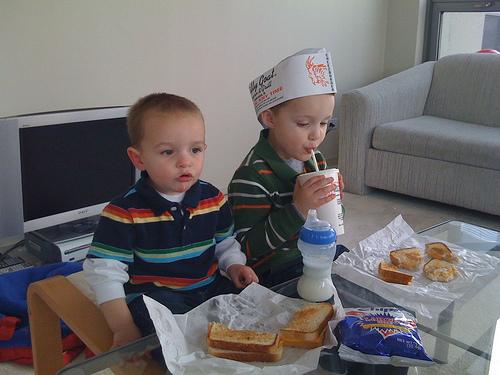Are both children wearing striped shirts?
Write a very short answer. Yes. What kind of food is the kid on the left eating?
Write a very short answer. Grilled cheese. Is the child on the left wearing a hat?
Give a very brief answer. No. 